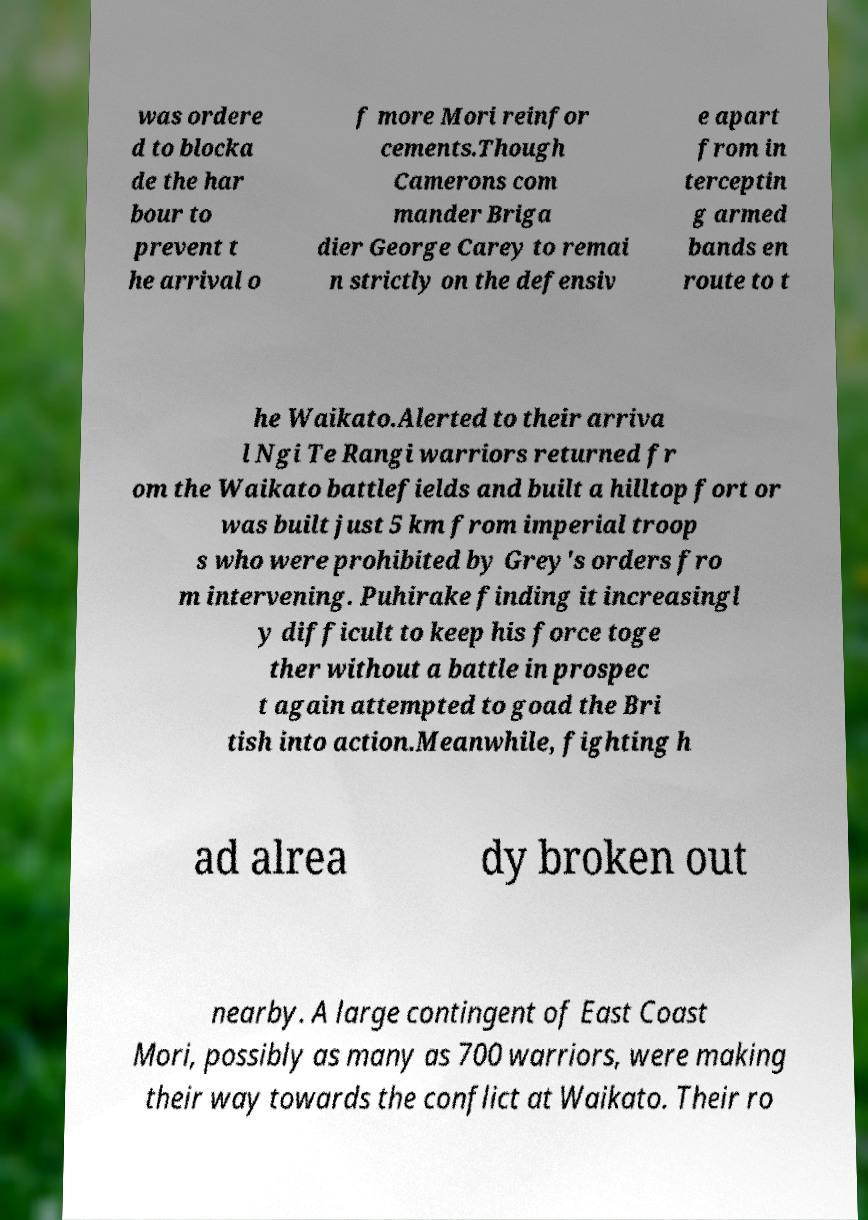For documentation purposes, I need the text within this image transcribed. Could you provide that? was ordere d to blocka de the har bour to prevent t he arrival o f more Mori reinfor cements.Though Camerons com mander Briga dier George Carey to remai n strictly on the defensiv e apart from in terceptin g armed bands en route to t he Waikato.Alerted to their arriva l Ngi Te Rangi warriors returned fr om the Waikato battlefields and built a hilltop fort or was built just 5 km from imperial troop s who were prohibited by Grey's orders fro m intervening. Puhirake finding it increasingl y difficult to keep his force toge ther without a battle in prospec t again attempted to goad the Bri tish into action.Meanwhile, fighting h ad alrea dy broken out nearby. A large contingent of East Coast Mori, possibly as many as 700 warriors, were making their way towards the conflict at Waikato. Their ro 